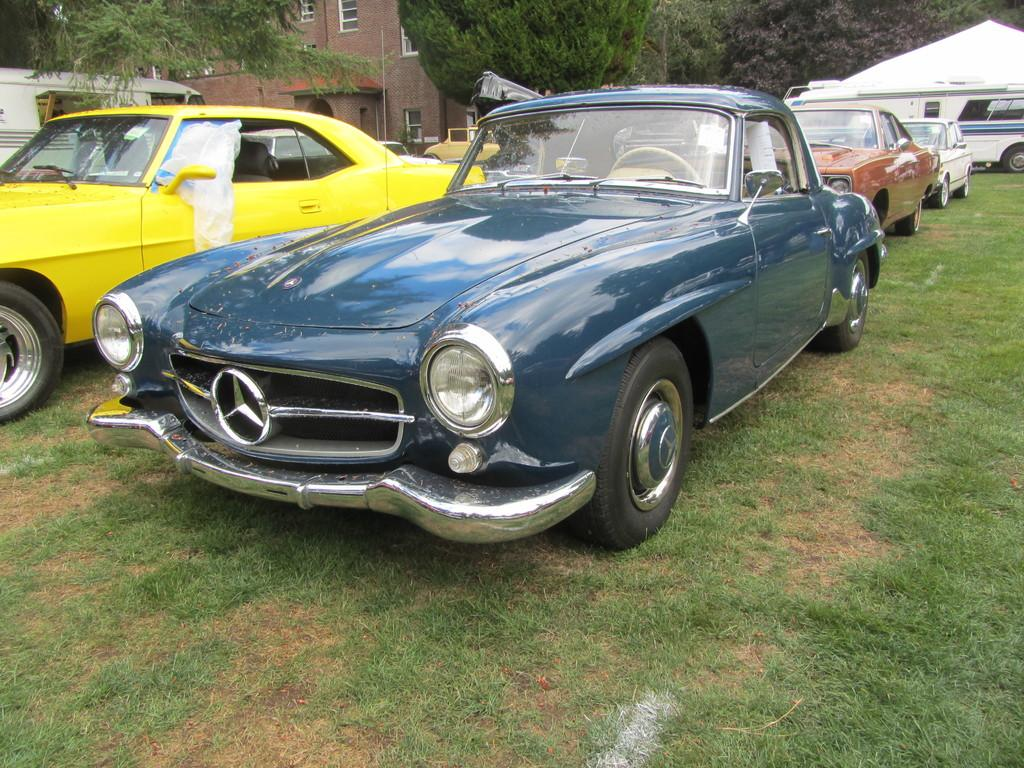What types of vehicles are in the image? The image contains vehicles, but the specific types are not mentioned. What can be seen in the background of the image? There is a building, trees, and a tent in the background of the image. What is the ground surface like in the image? The ground surface at the bottom of the image is grass. Where is the drum being played during the meeting in the image? There is no drum or meeting present in the image. How many people are sneezing in the image? There is no sneezing or indication of people in the image. 